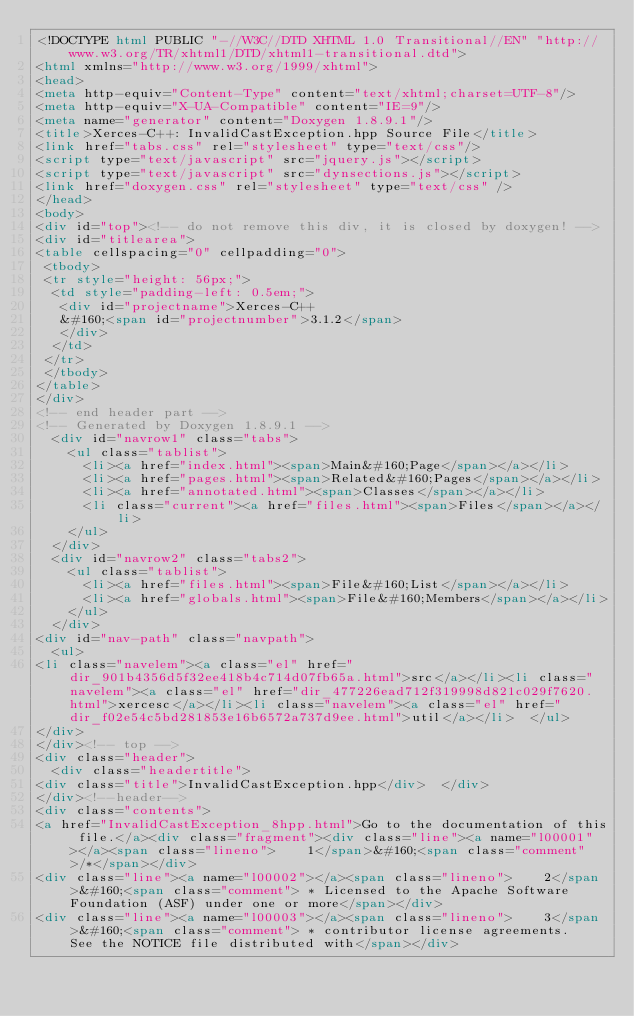Convert code to text. <code><loc_0><loc_0><loc_500><loc_500><_HTML_><!DOCTYPE html PUBLIC "-//W3C//DTD XHTML 1.0 Transitional//EN" "http://www.w3.org/TR/xhtml1/DTD/xhtml1-transitional.dtd">
<html xmlns="http://www.w3.org/1999/xhtml">
<head>
<meta http-equiv="Content-Type" content="text/xhtml;charset=UTF-8"/>
<meta http-equiv="X-UA-Compatible" content="IE=9"/>
<meta name="generator" content="Doxygen 1.8.9.1"/>
<title>Xerces-C++: InvalidCastException.hpp Source File</title>
<link href="tabs.css" rel="stylesheet" type="text/css"/>
<script type="text/javascript" src="jquery.js"></script>
<script type="text/javascript" src="dynsections.js"></script>
<link href="doxygen.css" rel="stylesheet" type="text/css" />
</head>
<body>
<div id="top"><!-- do not remove this div, it is closed by doxygen! -->
<div id="titlearea">
<table cellspacing="0" cellpadding="0">
 <tbody>
 <tr style="height: 56px;">
  <td style="padding-left: 0.5em;">
   <div id="projectname">Xerces-C++
   &#160;<span id="projectnumber">3.1.2</span>
   </div>
  </td>
 </tr>
 </tbody>
</table>
</div>
<!-- end header part -->
<!-- Generated by Doxygen 1.8.9.1 -->
  <div id="navrow1" class="tabs">
    <ul class="tablist">
      <li><a href="index.html"><span>Main&#160;Page</span></a></li>
      <li><a href="pages.html"><span>Related&#160;Pages</span></a></li>
      <li><a href="annotated.html"><span>Classes</span></a></li>
      <li class="current"><a href="files.html"><span>Files</span></a></li>
    </ul>
  </div>
  <div id="navrow2" class="tabs2">
    <ul class="tablist">
      <li><a href="files.html"><span>File&#160;List</span></a></li>
      <li><a href="globals.html"><span>File&#160;Members</span></a></li>
    </ul>
  </div>
<div id="nav-path" class="navpath">
  <ul>
<li class="navelem"><a class="el" href="dir_901b4356d5f32ee418b4c714d07fb65a.html">src</a></li><li class="navelem"><a class="el" href="dir_477226ead712f319998d821c029f7620.html">xercesc</a></li><li class="navelem"><a class="el" href="dir_f02e54c5bd281853e16b6572a737d9ee.html">util</a></li>  </ul>
</div>
</div><!-- top -->
<div class="header">
  <div class="headertitle">
<div class="title">InvalidCastException.hpp</div>  </div>
</div><!--header-->
<div class="contents">
<a href="InvalidCastException_8hpp.html">Go to the documentation of this file.</a><div class="fragment"><div class="line"><a name="l00001"></a><span class="lineno">    1</span>&#160;<span class="comment">/*</span></div>
<div class="line"><a name="l00002"></a><span class="lineno">    2</span>&#160;<span class="comment"> * Licensed to the Apache Software Foundation (ASF) under one or more</span></div>
<div class="line"><a name="l00003"></a><span class="lineno">    3</span>&#160;<span class="comment"> * contributor license agreements.  See the NOTICE file distributed with</span></div></code> 